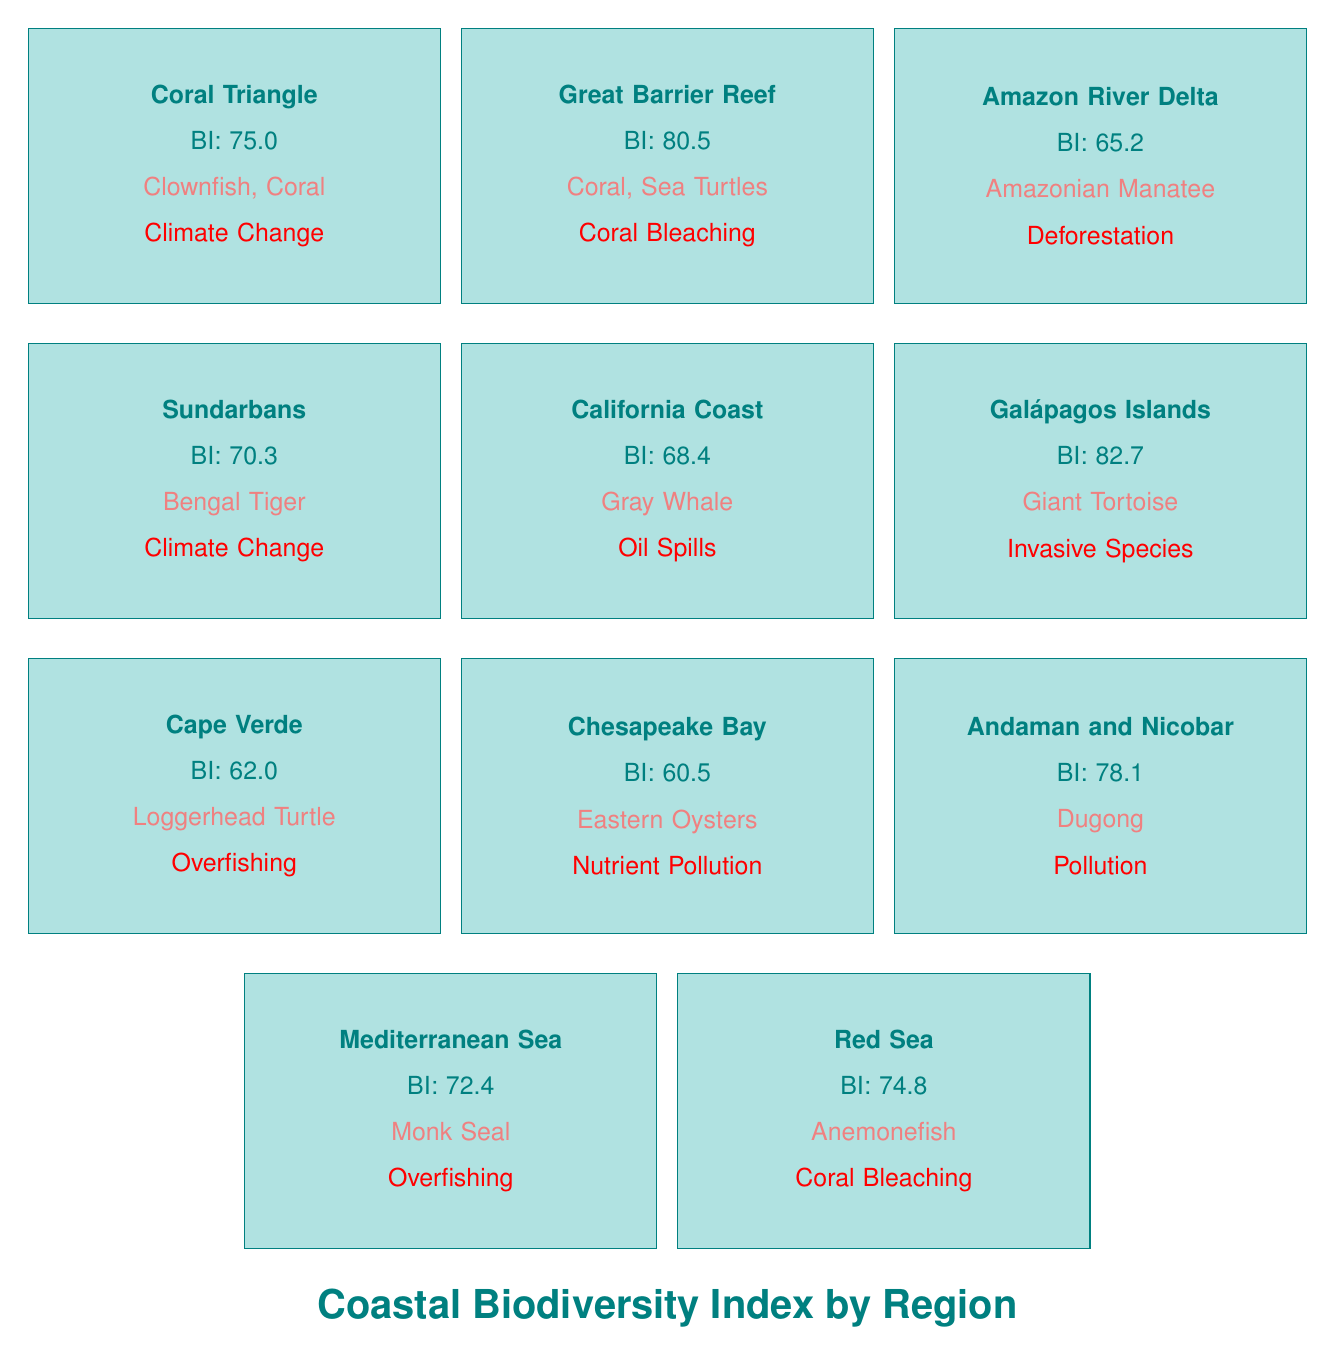What is the Biodiversity Index of the Great Barrier Reef? The table lists the Great Barrier Reef with a Biodiversity Index of 80.5. The value is directly stated in the specified region box.
Answer: 80.5 Which region has the highest Biodiversity Index? By reviewing the Biodiversity Index values for each region, the table shows that the Galápagos Islands have the highest value at 82.7.
Answer: Galápagos Islands Is the Biodiversity Index of Cape Verde above 70? The table shows that Cape Verde has a Biodiversity Index of 62.0, which is clearly below 70. Thus, the answer is no.
Answer: No What are the key species found in the Coral Triangle? The table indicates that the key species in the Coral Triangle include Clownfish, Coral, and Giant Clam. These are listed under the designated region.
Answer: Clownfish, Coral, Giant Clam What is the difference in Biodiversity Index between the Galápagos Islands and the Chesapeake Bay? The Galápagos Islands have a Biodiversity Index of 82.7 and Chesapeake Bay has an index of 60.5. To find the difference, subtract 60.5 from 82.7: 82.7 - 60.5 = 22.2.
Answer: 22.2 Which region faces threats from both Climate Change and Overfishing? The Coral Triangle is threatened by Climate Change and Overfishing, as indicated in the threats section of the table, fulfilling both conditions simultaneously.
Answer: Coral Triangle What is the average Biodiversity Index of the regions listed? First, sum all the Biodiversity Index values: 75.0 + 80.5 + 65.2 + 70.3 + 68.4 + 82.7 + 62.0 + 60.5 + 78.1 + 72.4 + 74.8 =  82.7. There are 11 regions, so the average is 756.0 / 11 ≈ 68.73.
Answer: 68.73 Which regions are threatened by Pollution? The regions facing Pollution as a threat include the Amazon River Delta, Cape Verde, Chesapeake Bay, Andaman and Nicobar Islands, and the Coral Triangle, according to the threats listed.
Answer: Amazon River Delta, Cape Verde, Chesapeake Bay, Andaman and Nicobar Islands, Coral Triangle Is there a region where the Biodiversity Index is lower than 65? Yes, the Chesapeake Bay has a Biodiversity Index of 60.5, which is lower than 65 as stated in the table.
Answer: Yes 